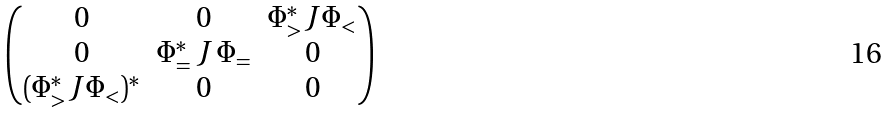<formula> <loc_0><loc_0><loc_500><loc_500>\begin{pmatrix} 0 & 0 & \Phi _ { > } ^ { * } J \Phi _ { < } \\ 0 & \Phi _ { = } ^ { * } \, J \, \Phi _ { = } & 0 \\ ( \Phi _ { > } ^ { * } J \Phi _ { < } ) ^ { * } & 0 & 0 \end{pmatrix}</formula> 